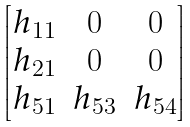Convert formula to latex. <formula><loc_0><loc_0><loc_500><loc_500>\begin{bmatrix} h _ { 1 1 } & 0 & 0 \\ h _ { 2 1 } & 0 & 0 \\ h _ { 5 1 } & h _ { 5 3 } & h _ { 5 4 } \end{bmatrix}</formula> 